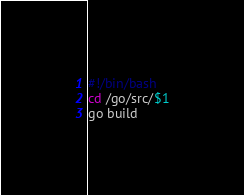<code> <loc_0><loc_0><loc_500><loc_500><_Bash_>#!/bin/bash
cd /go/src/$1
go build

</code> 